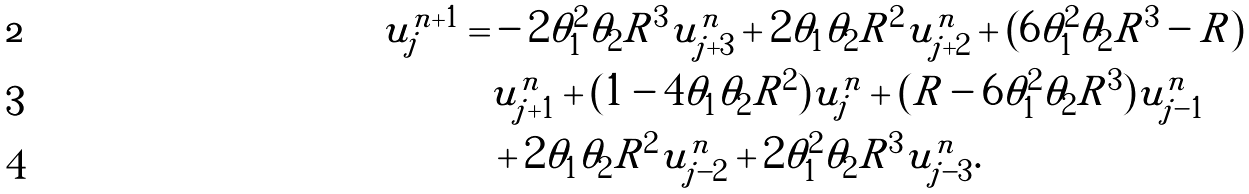<formula> <loc_0><loc_0><loc_500><loc_500>u ^ { n + 1 } _ { j } = & - 2 \theta _ { 1 } ^ { 2 } \theta _ { 2 } R ^ { 3 } u ^ { n } _ { j + 3 } + 2 \theta _ { 1 } \theta _ { 2 } R ^ { 2 } u ^ { n } _ { j + 2 } + ( 6 \theta _ { 1 } ^ { 2 } \theta _ { 2 } R ^ { 3 } - R ) \\ & u ^ { n } _ { j + 1 } + ( 1 - 4 \theta _ { 1 } \theta _ { 2 } R ^ { 2 } ) u ^ { n } _ { j } + ( R - 6 \theta _ { 1 } ^ { 2 } \theta _ { 2 } R ^ { 3 } ) u ^ { n } _ { j - 1 } \\ & + 2 \theta _ { 1 } \theta _ { 2 } R ^ { 2 } u ^ { n } _ { j - 2 } + 2 \theta _ { 1 } ^ { 2 } \theta _ { 2 } R ^ { 3 } u ^ { n } _ { j - 3 } .</formula> 